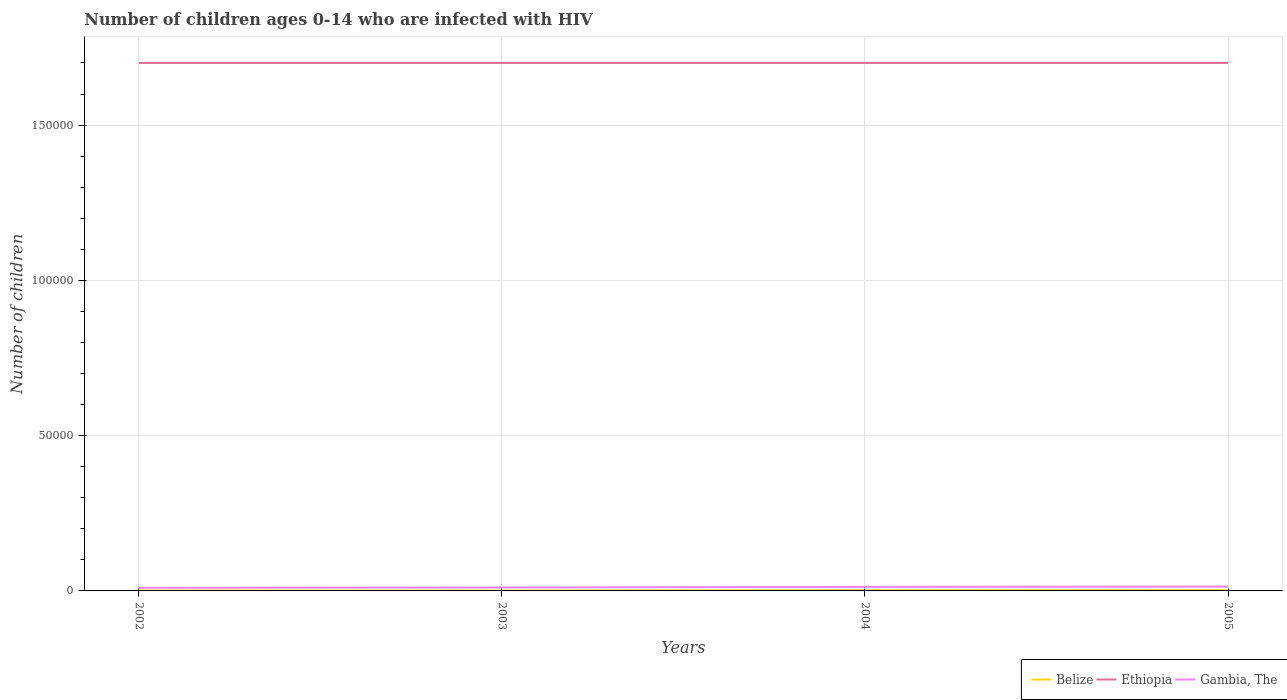Does the line corresponding to Gambia, The intersect with the line corresponding to Ethiopia?
Your answer should be compact. No. Across all years, what is the maximum number of HIV infected children in Belize?
Offer a terse response. 100. In which year was the number of HIV infected children in Gambia, The maximum?
Your response must be concise. 2002. What is the difference between the highest and the second highest number of HIV infected children in Ethiopia?
Ensure brevity in your answer.  0. What is the difference between the highest and the lowest number of HIV infected children in Belize?
Your response must be concise. 2. Is the number of HIV infected children in Gambia, The strictly greater than the number of HIV infected children in Belize over the years?
Offer a very short reply. No. How many lines are there?
Offer a very short reply. 3. Are the values on the major ticks of Y-axis written in scientific E-notation?
Ensure brevity in your answer.  No. Does the graph contain any zero values?
Give a very brief answer. No. How are the legend labels stacked?
Make the answer very short. Horizontal. What is the title of the graph?
Your answer should be very brief. Number of children ages 0-14 who are infected with HIV. What is the label or title of the Y-axis?
Your response must be concise. Number of children. What is the Number of children of Ethiopia in 2002?
Keep it short and to the point. 1.70e+05. What is the Number of children in Belize in 2003?
Give a very brief answer. 100. What is the Number of children in Ethiopia in 2003?
Provide a succinct answer. 1.70e+05. What is the Number of children of Gambia, The in 2003?
Your response must be concise. 1100. What is the Number of children in Gambia, The in 2004?
Make the answer very short. 1300. What is the Number of children in Belize in 2005?
Provide a succinct answer. 200. What is the Number of children in Gambia, The in 2005?
Provide a succinct answer. 1400. Across all years, what is the maximum Number of children in Belize?
Make the answer very short. 200. Across all years, what is the maximum Number of children in Gambia, The?
Offer a very short reply. 1400. What is the total Number of children in Belize in the graph?
Give a very brief answer. 600. What is the total Number of children of Ethiopia in the graph?
Keep it short and to the point. 6.80e+05. What is the total Number of children in Gambia, The in the graph?
Provide a short and direct response. 4800. What is the difference between the Number of children in Ethiopia in 2002 and that in 2003?
Provide a succinct answer. 0. What is the difference between the Number of children in Gambia, The in 2002 and that in 2003?
Your response must be concise. -100. What is the difference between the Number of children in Belize in 2002 and that in 2004?
Keep it short and to the point. -100. What is the difference between the Number of children of Ethiopia in 2002 and that in 2004?
Your answer should be very brief. 0. What is the difference between the Number of children of Gambia, The in 2002 and that in 2004?
Give a very brief answer. -300. What is the difference between the Number of children in Belize in 2002 and that in 2005?
Ensure brevity in your answer.  -100. What is the difference between the Number of children of Ethiopia in 2002 and that in 2005?
Your answer should be compact. 0. What is the difference between the Number of children in Gambia, The in 2002 and that in 2005?
Your answer should be compact. -400. What is the difference between the Number of children in Belize in 2003 and that in 2004?
Your response must be concise. -100. What is the difference between the Number of children of Ethiopia in 2003 and that in 2004?
Your answer should be compact. 0. What is the difference between the Number of children in Gambia, The in 2003 and that in 2004?
Make the answer very short. -200. What is the difference between the Number of children of Belize in 2003 and that in 2005?
Ensure brevity in your answer.  -100. What is the difference between the Number of children of Ethiopia in 2003 and that in 2005?
Provide a short and direct response. 0. What is the difference between the Number of children in Gambia, The in 2003 and that in 2005?
Your answer should be compact. -300. What is the difference between the Number of children in Gambia, The in 2004 and that in 2005?
Offer a terse response. -100. What is the difference between the Number of children in Belize in 2002 and the Number of children in Ethiopia in 2003?
Provide a short and direct response. -1.70e+05. What is the difference between the Number of children of Belize in 2002 and the Number of children of Gambia, The in 2003?
Make the answer very short. -1000. What is the difference between the Number of children of Ethiopia in 2002 and the Number of children of Gambia, The in 2003?
Give a very brief answer. 1.69e+05. What is the difference between the Number of children in Belize in 2002 and the Number of children in Ethiopia in 2004?
Offer a terse response. -1.70e+05. What is the difference between the Number of children of Belize in 2002 and the Number of children of Gambia, The in 2004?
Offer a terse response. -1200. What is the difference between the Number of children in Ethiopia in 2002 and the Number of children in Gambia, The in 2004?
Provide a short and direct response. 1.69e+05. What is the difference between the Number of children of Belize in 2002 and the Number of children of Ethiopia in 2005?
Ensure brevity in your answer.  -1.70e+05. What is the difference between the Number of children of Belize in 2002 and the Number of children of Gambia, The in 2005?
Your response must be concise. -1300. What is the difference between the Number of children of Ethiopia in 2002 and the Number of children of Gambia, The in 2005?
Your answer should be compact. 1.69e+05. What is the difference between the Number of children in Belize in 2003 and the Number of children in Ethiopia in 2004?
Ensure brevity in your answer.  -1.70e+05. What is the difference between the Number of children in Belize in 2003 and the Number of children in Gambia, The in 2004?
Your answer should be compact. -1200. What is the difference between the Number of children of Ethiopia in 2003 and the Number of children of Gambia, The in 2004?
Your response must be concise. 1.69e+05. What is the difference between the Number of children of Belize in 2003 and the Number of children of Ethiopia in 2005?
Provide a succinct answer. -1.70e+05. What is the difference between the Number of children of Belize in 2003 and the Number of children of Gambia, The in 2005?
Your answer should be compact. -1300. What is the difference between the Number of children in Ethiopia in 2003 and the Number of children in Gambia, The in 2005?
Keep it short and to the point. 1.69e+05. What is the difference between the Number of children in Belize in 2004 and the Number of children in Ethiopia in 2005?
Provide a succinct answer. -1.70e+05. What is the difference between the Number of children in Belize in 2004 and the Number of children in Gambia, The in 2005?
Your response must be concise. -1200. What is the difference between the Number of children of Ethiopia in 2004 and the Number of children of Gambia, The in 2005?
Your response must be concise. 1.69e+05. What is the average Number of children in Belize per year?
Give a very brief answer. 150. What is the average Number of children in Ethiopia per year?
Provide a short and direct response. 1.70e+05. What is the average Number of children in Gambia, The per year?
Provide a short and direct response. 1200. In the year 2002, what is the difference between the Number of children in Belize and Number of children in Ethiopia?
Your answer should be very brief. -1.70e+05. In the year 2002, what is the difference between the Number of children of Belize and Number of children of Gambia, The?
Provide a succinct answer. -900. In the year 2002, what is the difference between the Number of children in Ethiopia and Number of children in Gambia, The?
Ensure brevity in your answer.  1.69e+05. In the year 2003, what is the difference between the Number of children of Belize and Number of children of Ethiopia?
Make the answer very short. -1.70e+05. In the year 2003, what is the difference between the Number of children of Belize and Number of children of Gambia, The?
Your answer should be compact. -1000. In the year 2003, what is the difference between the Number of children of Ethiopia and Number of children of Gambia, The?
Your answer should be very brief. 1.69e+05. In the year 2004, what is the difference between the Number of children in Belize and Number of children in Ethiopia?
Offer a very short reply. -1.70e+05. In the year 2004, what is the difference between the Number of children in Belize and Number of children in Gambia, The?
Make the answer very short. -1100. In the year 2004, what is the difference between the Number of children in Ethiopia and Number of children in Gambia, The?
Provide a succinct answer. 1.69e+05. In the year 2005, what is the difference between the Number of children of Belize and Number of children of Ethiopia?
Provide a succinct answer. -1.70e+05. In the year 2005, what is the difference between the Number of children in Belize and Number of children in Gambia, The?
Offer a very short reply. -1200. In the year 2005, what is the difference between the Number of children in Ethiopia and Number of children in Gambia, The?
Offer a very short reply. 1.69e+05. What is the ratio of the Number of children in Belize in 2002 to that in 2004?
Make the answer very short. 0.5. What is the ratio of the Number of children of Ethiopia in 2002 to that in 2004?
Your answer should be very brief. 1. What is the ratio of the Number of children of Gambia, The in 2002 to that in 2004?
Your answer should be compact. 0.77. What is the ratio of the Number of children of Belize in 2003 to that in 2004?
Offer a terse response. 0.5. What is the ratio of the Number of children in Ethiopia in 2003 to that in 2004?
Your response must be concise. 1. What is the ratio of the Number of children in Gambia, The in 2003 to that in 2004?
Keep it short and to the point. 0.85. What is the ratio of the Number of children in Ethiopia in 2003 to that in 2005?
Offer a terse response. 1. What is the ratio of the Number of children of Gambia, The in 2003 to that in 2005?
Give a very brief answer. 0.79. What is the ratio of the Number of children in Ethiopia in 2004 to that in 2005?
Your answer should be compact. 1. What is the difference between the highest and the second highest Number of children of Belize?
Your answer should be very brief. 0. What is the difference between the highest and the second highest Number of children in Ethiopia?
Provide a succinct answer. 0. What is the difference between the highest and the second highest Number of children of Gambia, The?
Provide a succinct answer. 100. What is the difference between the highest and the lowest Number of children in Belize?
Keep it short and to the point. 100. What is the difference between the highest and the lowest Number of children of Ethiopia?
Give a very brief answer. 0. What is the difference between the highest and the lowest Number of children in Gambia, The?
Your response must be concise. 400. 